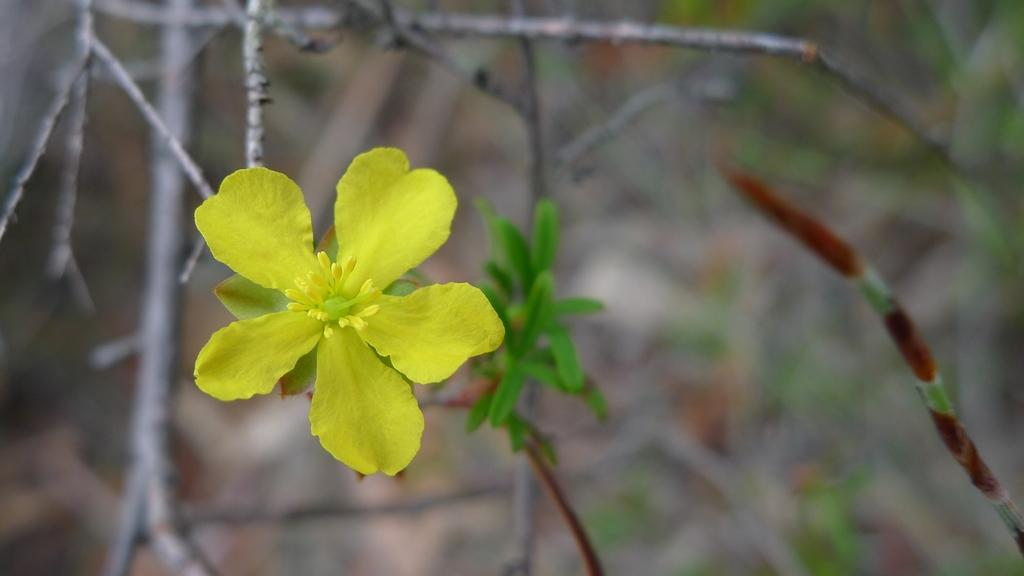What is the main subject in the foreground of the image? There is a yellow flower in the foreground of the image. Is the flower part of a larger plant? Yes, the flower is attached to a plant. What other objects can be seen in the image? There are sticks visible in the image. How would you describe the background of the image? The background of the image is blurred. What type of care is being provided to the harbor in the image? There is no harbor present in the image; it features a yellow flower and a blurred background. What type of ground is visible beneath the flower in the image? The ground is not visible in the image, as the focus is on the flower and the blurred background. 